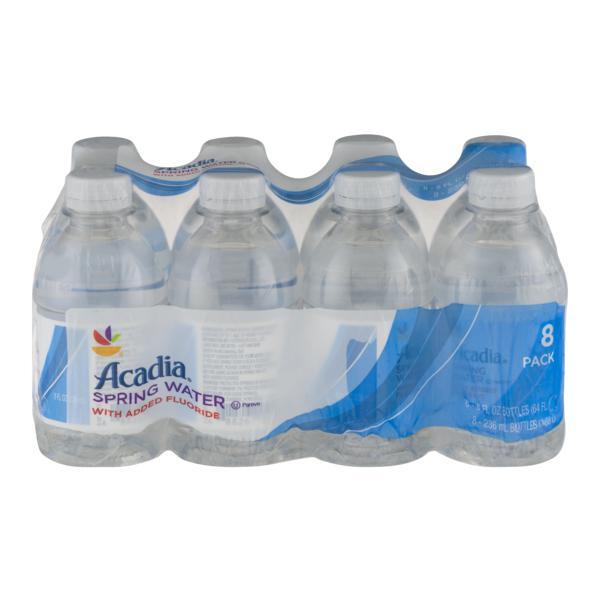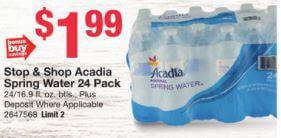The first image is the image on the left, the second image is the image on the right. For the images shown, is this caption "The left and right image contains at least eight bottle of water in a plastic wrap." true? Answer yes or no. Yes. The first image is the image on the left, the second image is the image on the right. Given the left and right images, does the statement "There are water bottles with two or more different labels and shapes." hold true? Answer yes or no. No. 